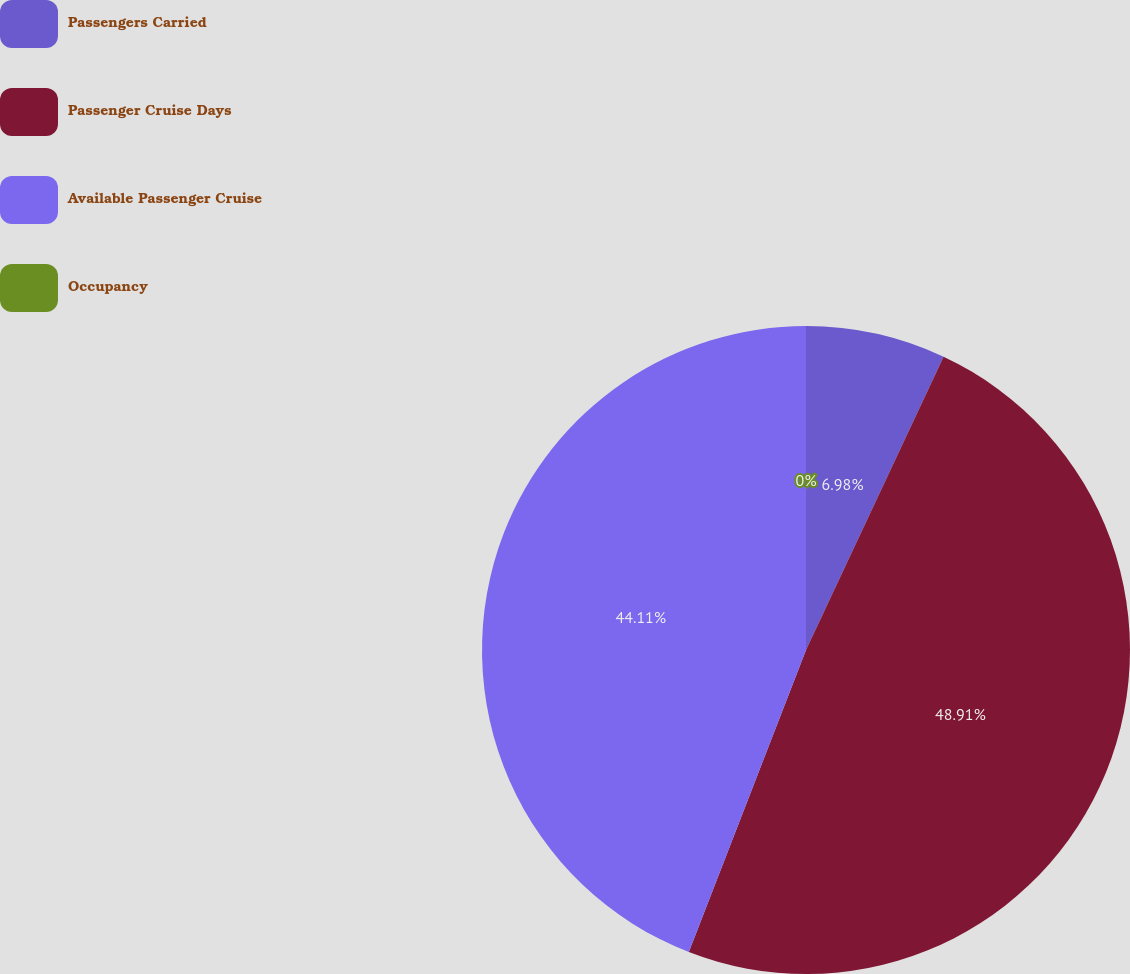Convert chart to OTSL. <chart><loc_0><loc_0><loc_500><loc_500><pie_chart><fcel>Passengers Carried<fcel>Passenger Cruise Days<fcel>Available Passenger Cruise<fcel>Occupancy<nl><fcel>6.98%<fcel>48.91%<fcel>44.11%<fcel>0.0%<nl></chart> 